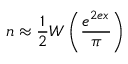<formula> <loc_0><loc_0><loc_500><loc_500>n \approx \frac { 1 } { 2 } W \left ( \frac { e ^ { 2 e x } } { \pi } \right )</formula> 